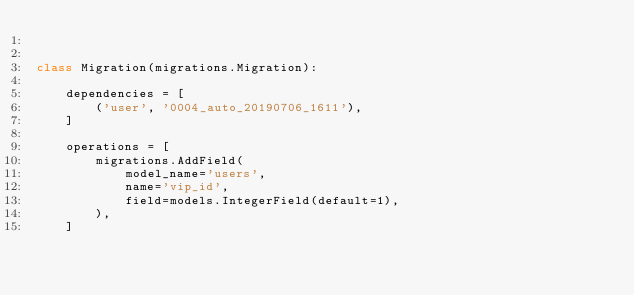Convert code to text. <code><loc_0><loc_0><loc_500><loc_500><_Python_>

class Migration(migrations.Migration):

    dependencies = [
        ('user', '0004_auto_20190706_1611'),
    ]

    operations = [
        migrations.AddField(
            model_name='users',
            name='vip_id',
            field=models.IntegerField(default=1),
        ),
    ]
</code> 